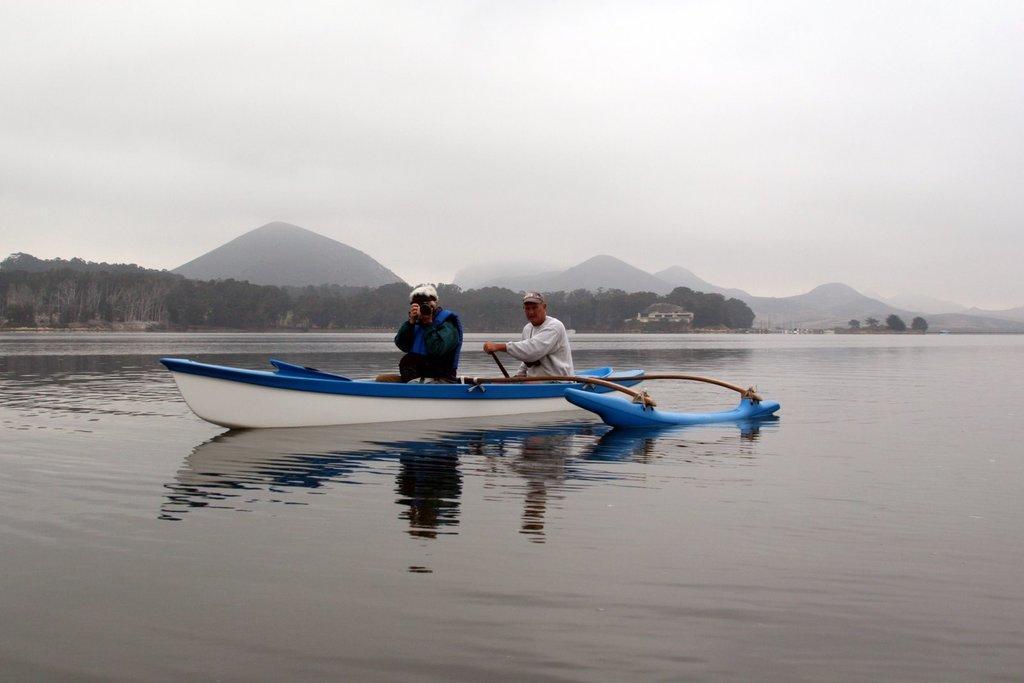How would you summarize this image in a sentence or two? In this picture I can see a boat in the water and couple of them seated in the boat and looks like a man in the front holding a camera in his hand and another man holding a pedal and I can see trees and a house and I can see hills and a cloudy sky. 